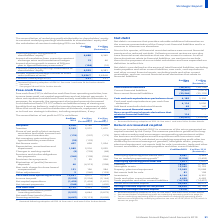According to Unilever Plc's financial document, How is the underlying operating profit calculated? underlying operating profit before tax multiplied by underlying effective tax rate. The document states: "x on underlying operating profit is calculated as underlying operating profit before tax multiplied by underlying effective tax rate of 25.5% (2018: 2..." Also, What is Return on Invested Capital (ROIC) ? measure of the return generated on capital invested by the Group. The document states: "Return on invested capital (ROIC) is a measure of the return generated on capital invested by the Group. The measure provides a guide rail for long- t..." Also, How is ROIC calculated? underlying operating profit after tax divided by the annual average of: goodwill, intangible assets, property, plant and equipment, net assets held for sale, inventories, trade and other current receivables, and trade payables and other current liabilities.. The document states: "ow returns and long payback. ROIC is calculated as underlying operating profit after tax divided by the annual average of: goodwill, intangible assets..." Also, can you calculate: What is the average Goodwill? To answer this question, I need to perform calculations using the financial data. The calculation is: (18,067 + 17,341) / 2, which equals 17704 (in millions). This is based on the information: "Goodwill 18,067 17,341 Goodwill 18,067 17,341..." The key data points involved are: 17,341, 18,067. Also, can you calculate: What is the increase / (decrease) in inventories? Based on the calculation: 4,164 - 4,301, the result is -137 (in millions). This is based on the information: "Inventories 4,164 4,301 Inventories 4,164 4,301..." The key data points involved are: 4,164, 4,301. Also, can you calculate: What is the percentage of tax on underlying operating profit before tax in 2019? Based on the calculation: 2,536 / 9,947, the result is 25.5 (percentage). This is based on the information: "Underlying operating profit before tax (b) 9,947 9,463 Tax on underlying operating profit (c) (2,536) (2,432)..." The key data points involved are: 2,536, 9,947. Also, What does Return on Invested Capital (ROIC) represent?  Based on the financial document, the answer is provides a guide rail for longterm value creation and encourages compounding reinvestment within the business and discipline around acquisitions with low returns and long payback. 